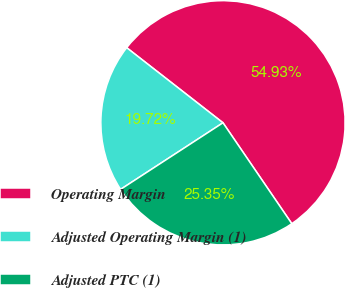Convert chart. <chart><loc_0><loc_0><loc_500><loc_500><pie_chart><fcel>Operating Margin<fcel>Adjusted Operating Margin (1)<fcel>Adjusted PTC (1)<nl><fcel>54.93%<fcel>19.72%<fcel>25.35%<nl></chart> 